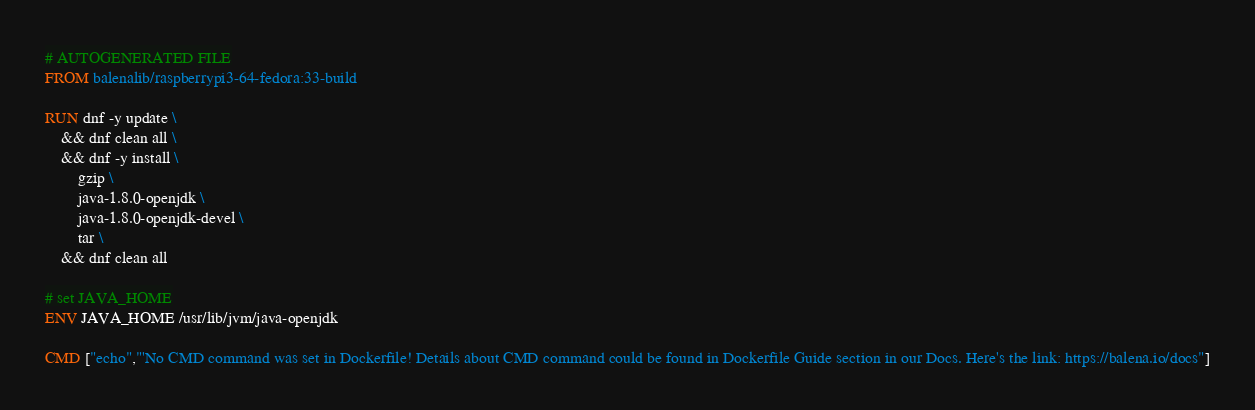<code> <loc_0><loc_0><loc_500><loc_500><_Dockerfile_># AUTOGENERATED FILE
FROM balenalib/raspberrypi3-64-fedora:33-build

RUN dnf -y update \
	&& dnf clean all \
	&& dnf -y install \
		gzip \
		java-1.8.0-openjdk \
		java-1.8.0-openjdk-devel \
		tar \
	&& dnf clean all

# set JAVA_HOME
ENV JAVA_HOME /usr/lib/jvm/java-openjdk

CMD ["echo","'No CMD command was set in Dockerfile! Details about CMD command could be found in Dockerfile Guide section in our Docs. Here's the link: https://balena.io/docs"]
</code> 